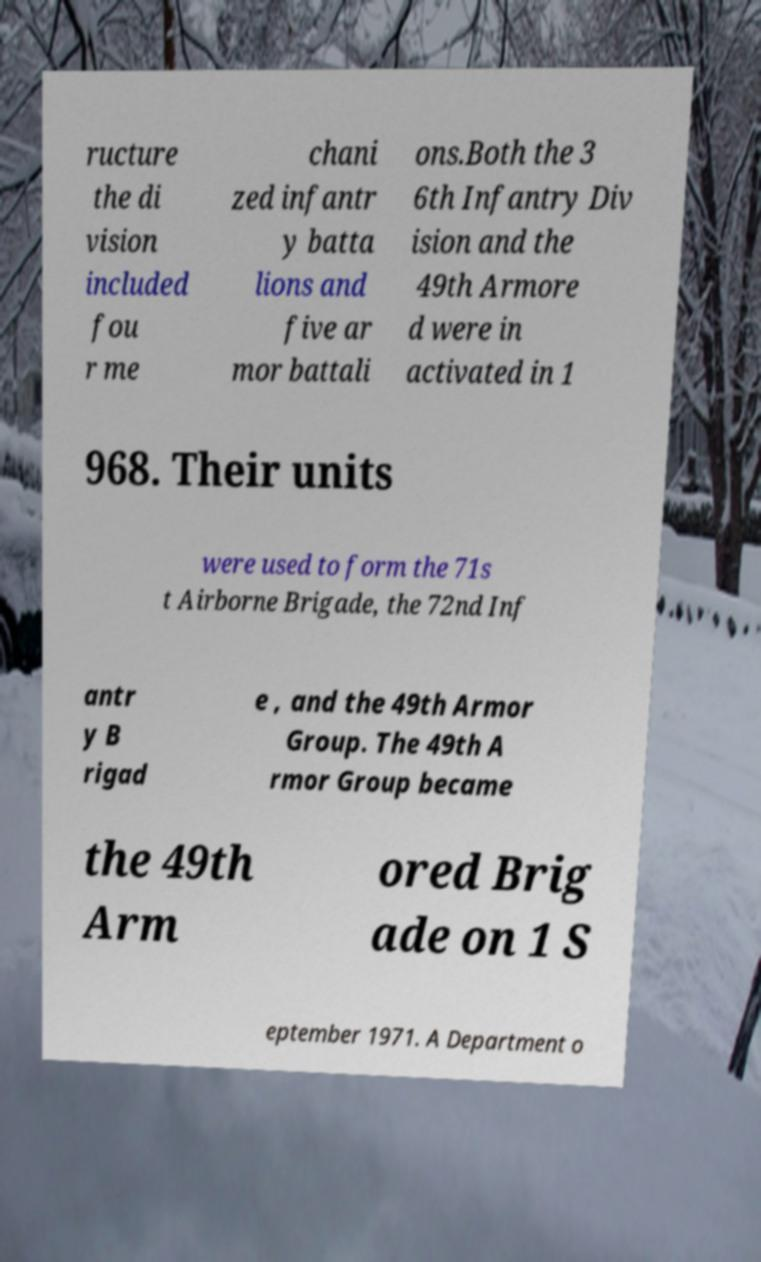Can you read and provide the text displayed in the image?This photo seems to have some interesting text. Can you extract and type it out for me? ructure the di vision included fou r me chani zed infantr y batta lions and five ar mor battali ons.Both the 3 6th Infantry Div ision and the 49th Armore d were in activated in 1 968. Their units were used to form the 71s t Airborne Brigade, the 72nd Inf antr y B rigad e , and the 49th Armor Group. The 49th A rmor Group became the 49th Arm ored Brig ade on 1 S eptember 1971. A Department o 